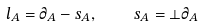Convert formula to latex. <formula><loc_0><loc_0><loc_500><loc_500>l _ { A } = \partial _ { A } - s _ { A } , \quad s _ { A } = \bot \partial _ { A }</formula> 